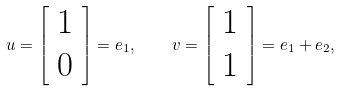<formula> <loc_0><loc_0><loc_500><loc_500>u = { \left [ \begin{array} { l } { 1 } \\ { 0 } \end{array} \right ] } = e _ { 1 } , \quad v = { \left [ \begin{array} { l } { 1 } \\ { 1 } \end{array} \right ] } = e _ { 1 } + e _ { 2 } ,</formula> 